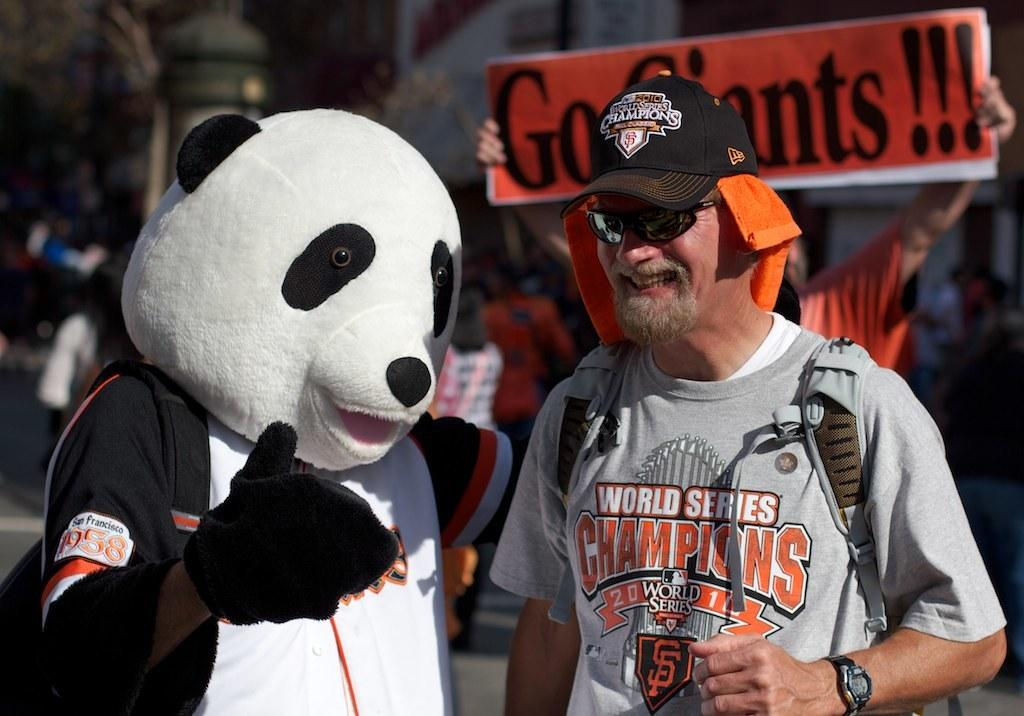<image>
Render a clear and concise summary of the photo. a man next to a panda with a world series shirt on 